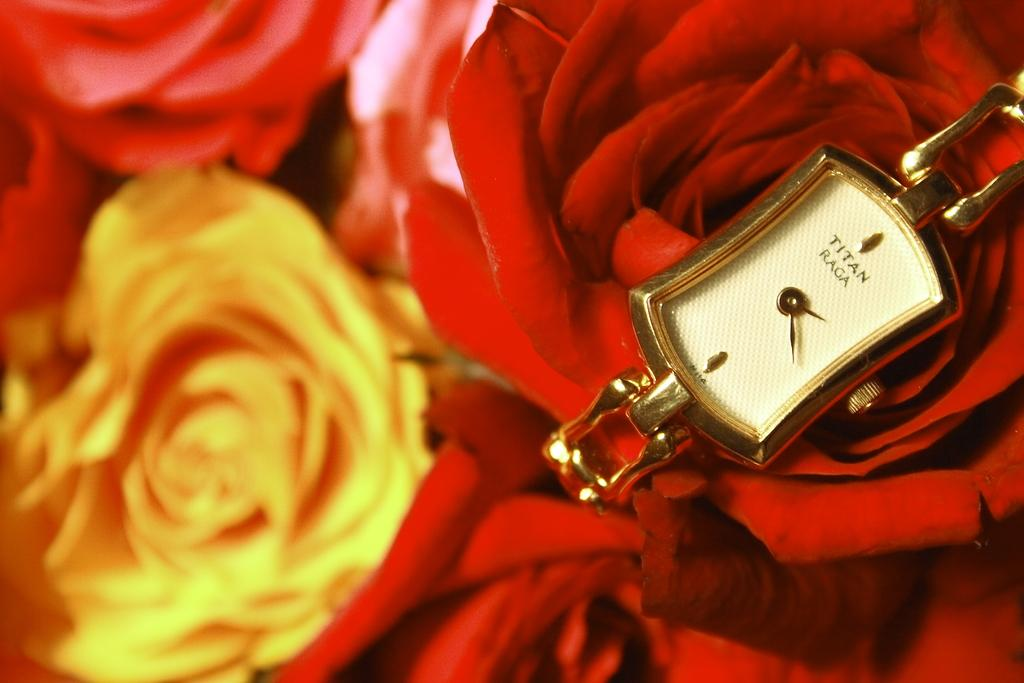<image>
Summarize the visual content of the image. A watch is displayed on roses, and its face reads "Titan Raga." 